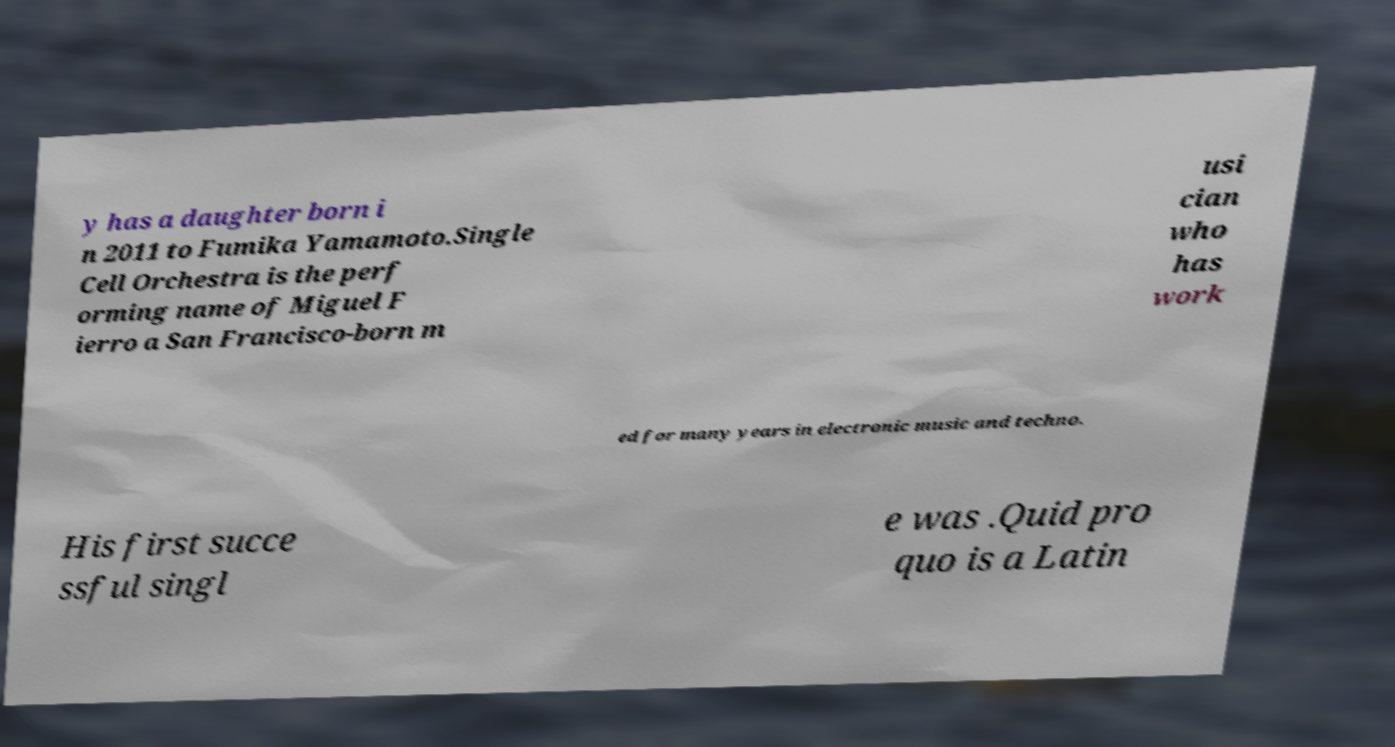Could you assist in decoding the text presented in this image and type it out clearly? y has a daughter born i n 2011 to Fumika Yamamoto.Single Cell Orchestra is the perf orming name of Miguel F ierro a San Francisco-born m usi cian who has work ed for many years in electronic music and techno. His first succe ssful singl e was .Quid pro quo is a Latin 